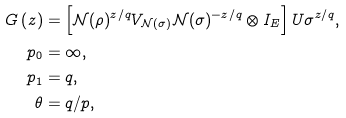Convert formula to latex. <formula><loc_0><loc_0><loc_500><loc_500>G \left ( z \right ) & = \left [ \mathcal { N } ( \rho ) ^ { z / q } V _ { \mathcal { N } ( \sigma ) } \mathcal { N } ( \sigma ) ^ { - z / q } \otimes I _ { E } \right ] U \sigma ^ { z / q } , \\ p _ { 0 } & = \infty , \\ p _ { 1 } & = q , \\ \theta & = q / p ,</formula> 